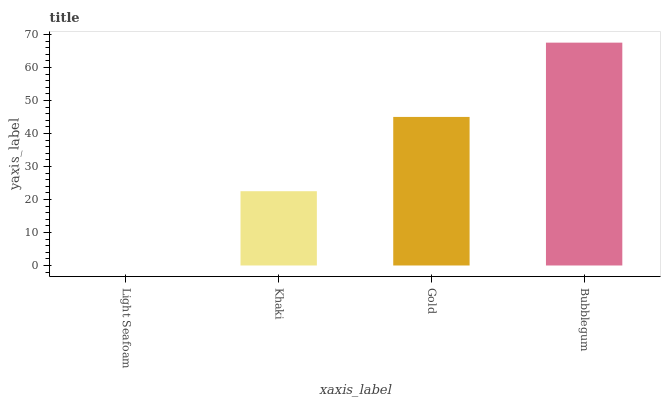Is Light Seafoam the minimum?
Answer yes or no. Yes. Is Bubblegum the maximum?
Answer yes or no. Yes. Is Khaki the minimum?
Answer yes or no. No. Is Khaki the maximum?
Answer yes or no. No. Is Khaki greater than Light Seafoam?
Answer yes or no. Yes. Is Light Seafoam less than Khaki?
Answer yes or no. Yes. Is Light Seafoam greater than Khaki?
Answer yes or no. No. Is Khaki less than Light Seafoam?
Answer yes or no. No. Is Gold the high median?
Answer yes or no. Yes. Is Khaki the low median?
Answer yes or no. Yes. Is Light Seafoam the high median?
Answer yes or no. No. Is Light Seafoam the low median?
Answer yes or no. No. 